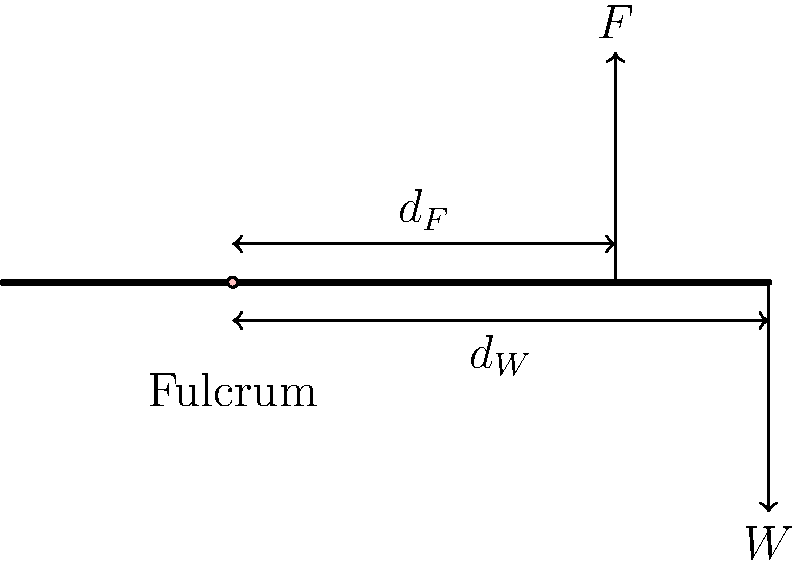In the biomechanical system shown above, which represents a simplified model of a human arm, what is the relationship between the force (F) and weight (W) when the system is in equilibrium? Express your answer in terms of the lever arms $d_F$ and $d_W$. To determine the relationship between force (F) and weight (W) when the system is in equilibrium, we need to follow these steps:

1. Recognize that this is a first-class lever system, with the fulcrum between the effort (force F) and the load (weight W).

2. Recall the principle of moments: for a system to be in equilibrium, the sum of clockwise moments must equal the sum of counterclockwise moments about any point.

3. Choose the fulcrum as the point about which to calculate moments.

4. The moment created by force F is clockwise and equal to $F \times d_F$.

5. The moment created by weight W is counterclockwise and equal to $W \times d_W$.

6. For equilibrium:
   $F \times d_F = W \times d_W$

7. Rearranging this equation gives us the relationship between F and W:
   $F = W \times \frac{d_W}{d_F}$

This equation shows that the force F required to balance the weight W is directly proportional to W and to the ratio of the lever arms.
Answer: $F = W \times \frac{d_W}{d_F}$ 